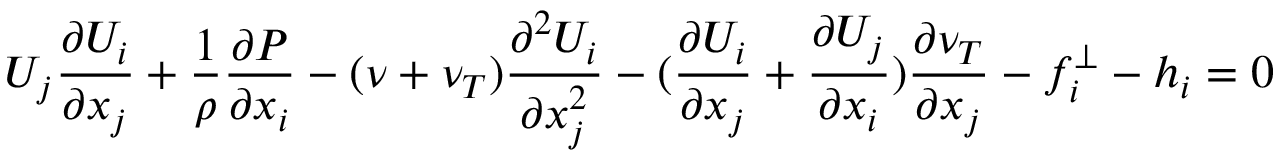Convert formula to latex. <formula><loc_0><loc_0><loc_500><loc_500>U _ { j } \frac { \partial U _ { i } } { \partial x _ { j } } + \frac { 1 } { \rho } \frac { \partial P } { \partial x _ { i } } - ( \nu + \nu _ { T } ) \frac { \partial ^ { 2 } U _ { i } } { \partial x _ { j } ^ { 2 } } - ( \frac { \partial U _ { i } } { \partial x _ { j } } + \frac { \partial U _ { j } } { \partial x _ { i } } ) \frac { \partial \nu _ { T } } { \partial x _ { j } } - f _ { i } ^ { \perp } - h _ { i } = 0</formula> 